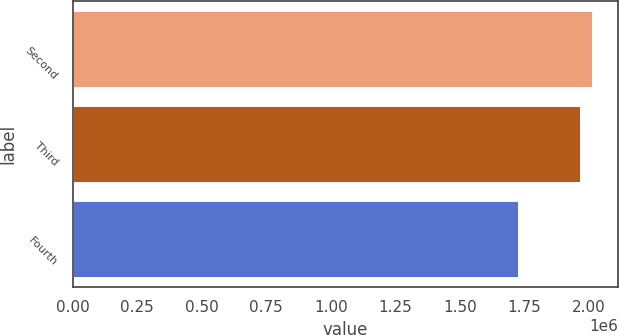<chart> <loc_0><loc_0><loc_500><loc_500><bar_chart><fcel>Second<fcel>Third<fcel>Fourth<nl><fcel>2.01098e+06<fcel>1.96578e+06<fcel>1.72665e+06<nl></chart> 